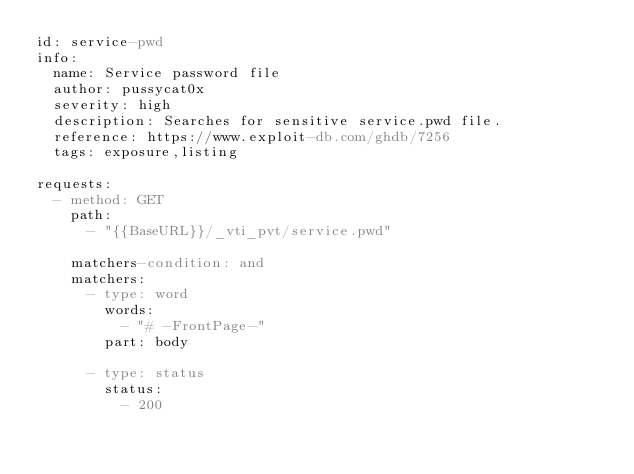Convert code to text. <code><loc_0><loc_0><loc_500><loc_500><_YAML_>id: service-pwd
info:
  name: Service password file
  author: pussycat0x
  severity: high
  description: Searches for sensitive service.pwd file.
  reference: https://www.exploit-db.com/ghdb/7256
  tags: exposure,listing

requests:
  - method: GET
    path:
      - "{{BaseURL}}/_vti_pvt/service.pwd"

    matchers-condition: and
    matchers:
      - type: word
        words:
          - "# -FrontPage-"
        part: body

      - type: status
        status:
          - 200
</code> 